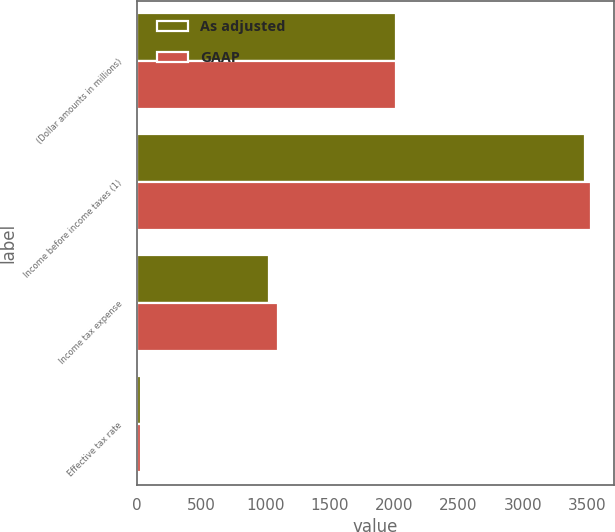Convert chart. <chart><loc_0><loc_0><loc_500><loc_500><stacked_bar_chart><ecel><fcel>(Dollar amounts in millions)<fcel>Income before income taxes (1)<fcel>Income tax expense<fcel>Effective tax rate<nl><fcel>As adjusted<fcel>2012<fcel>3488<fcel>1030<fcel>29.5<nl><fcel>GAAP<fcel>2012<fcel>3532<fcel>1094<fcel>31<nl></chart> 